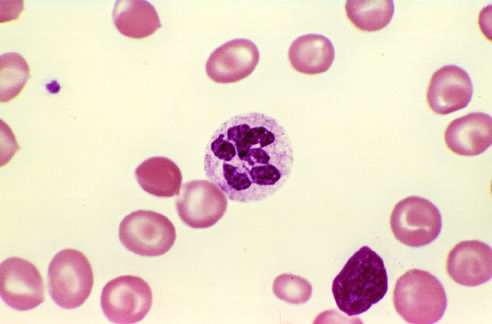what does a peripheral blood smear show?
Answer the question using a single word or phrase. A hyper-segmented neutrophil with a six-lobed nucleus 